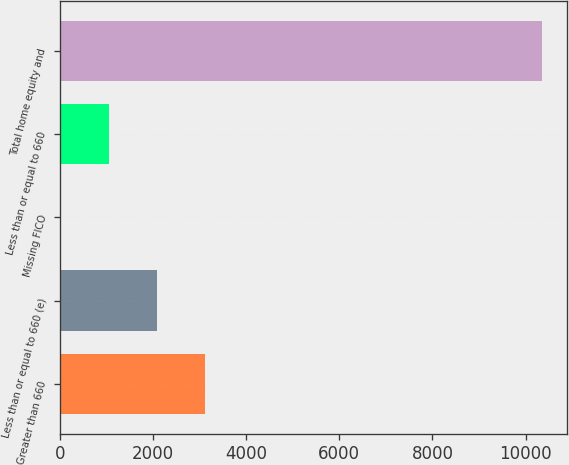Convert chart to OTSL. <chart><loc_0><loc_0><loc_500><loc_500><bar_chart><fcel>Greater than 660<fcel>Less than or equal to 660 (e)<fcel>Missing FICO<fcel>Less than or equal to 660<fcel>Total home equity and<nl><fcel>3119.5<fcel>2085<fcel>16<fcel>1050.5<fcel>10361<nl></chart> 